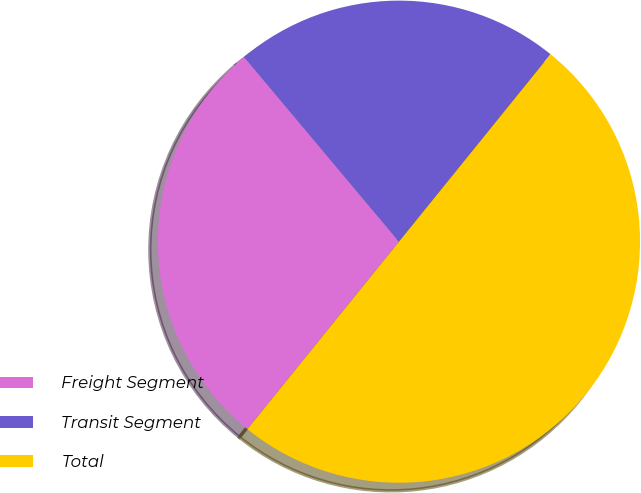<chart> <loc_0><loc_0><loc_500><loc_500><pie_chart><fcel>Freight Segment<fcel>Transit Segment<fcel>Total<nl><fcel>28.07%<fcel>21.93%<fcel>50.0%<nl></chart> 